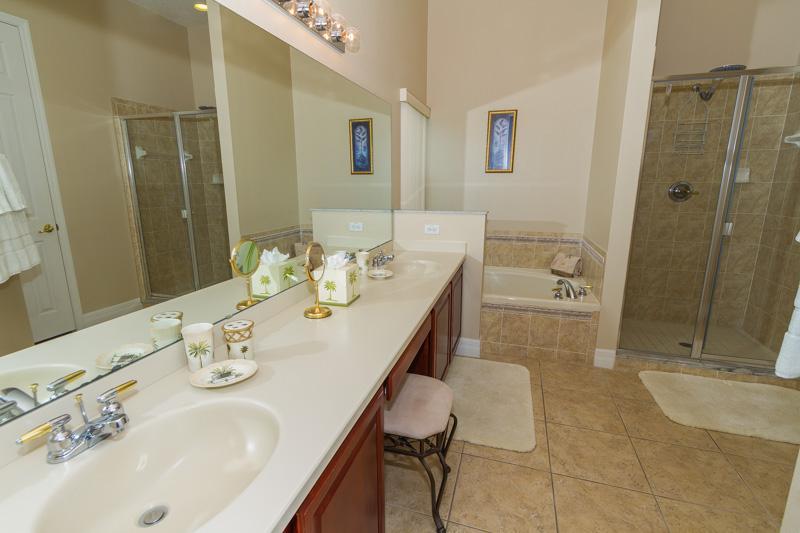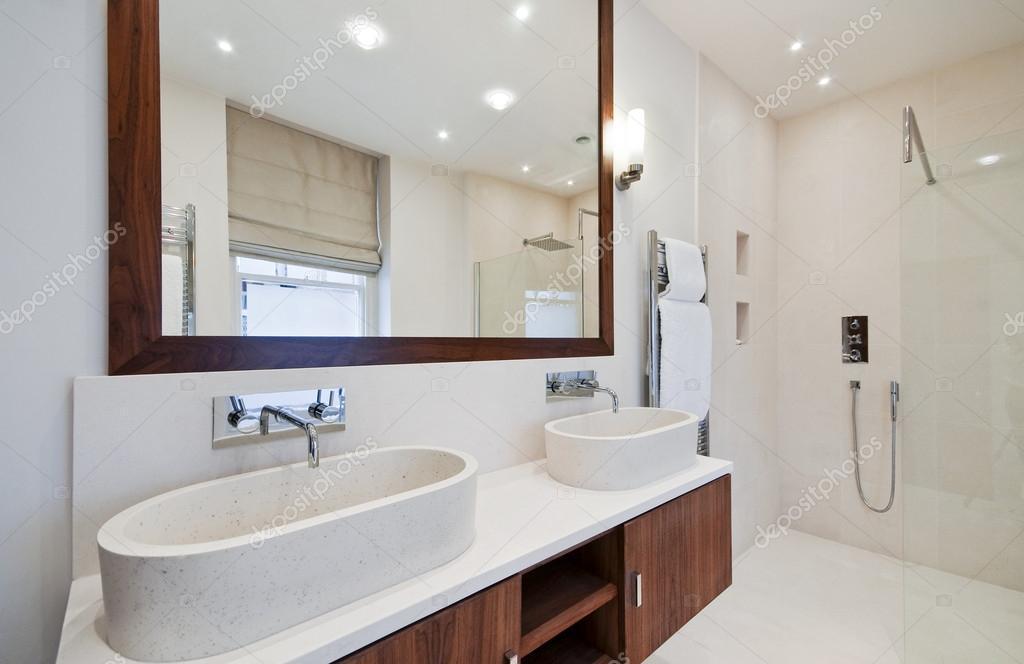The first image is the image on the left, the second image is the image on the right. Evaluate the accuracy of this statement regarding the images: "One image shows a seamless mirror over an undivided white 'trough' sink with multiple spouts over it, which has a white toilet with a tank behind it.". Is it true? Answer yes or no. No. 